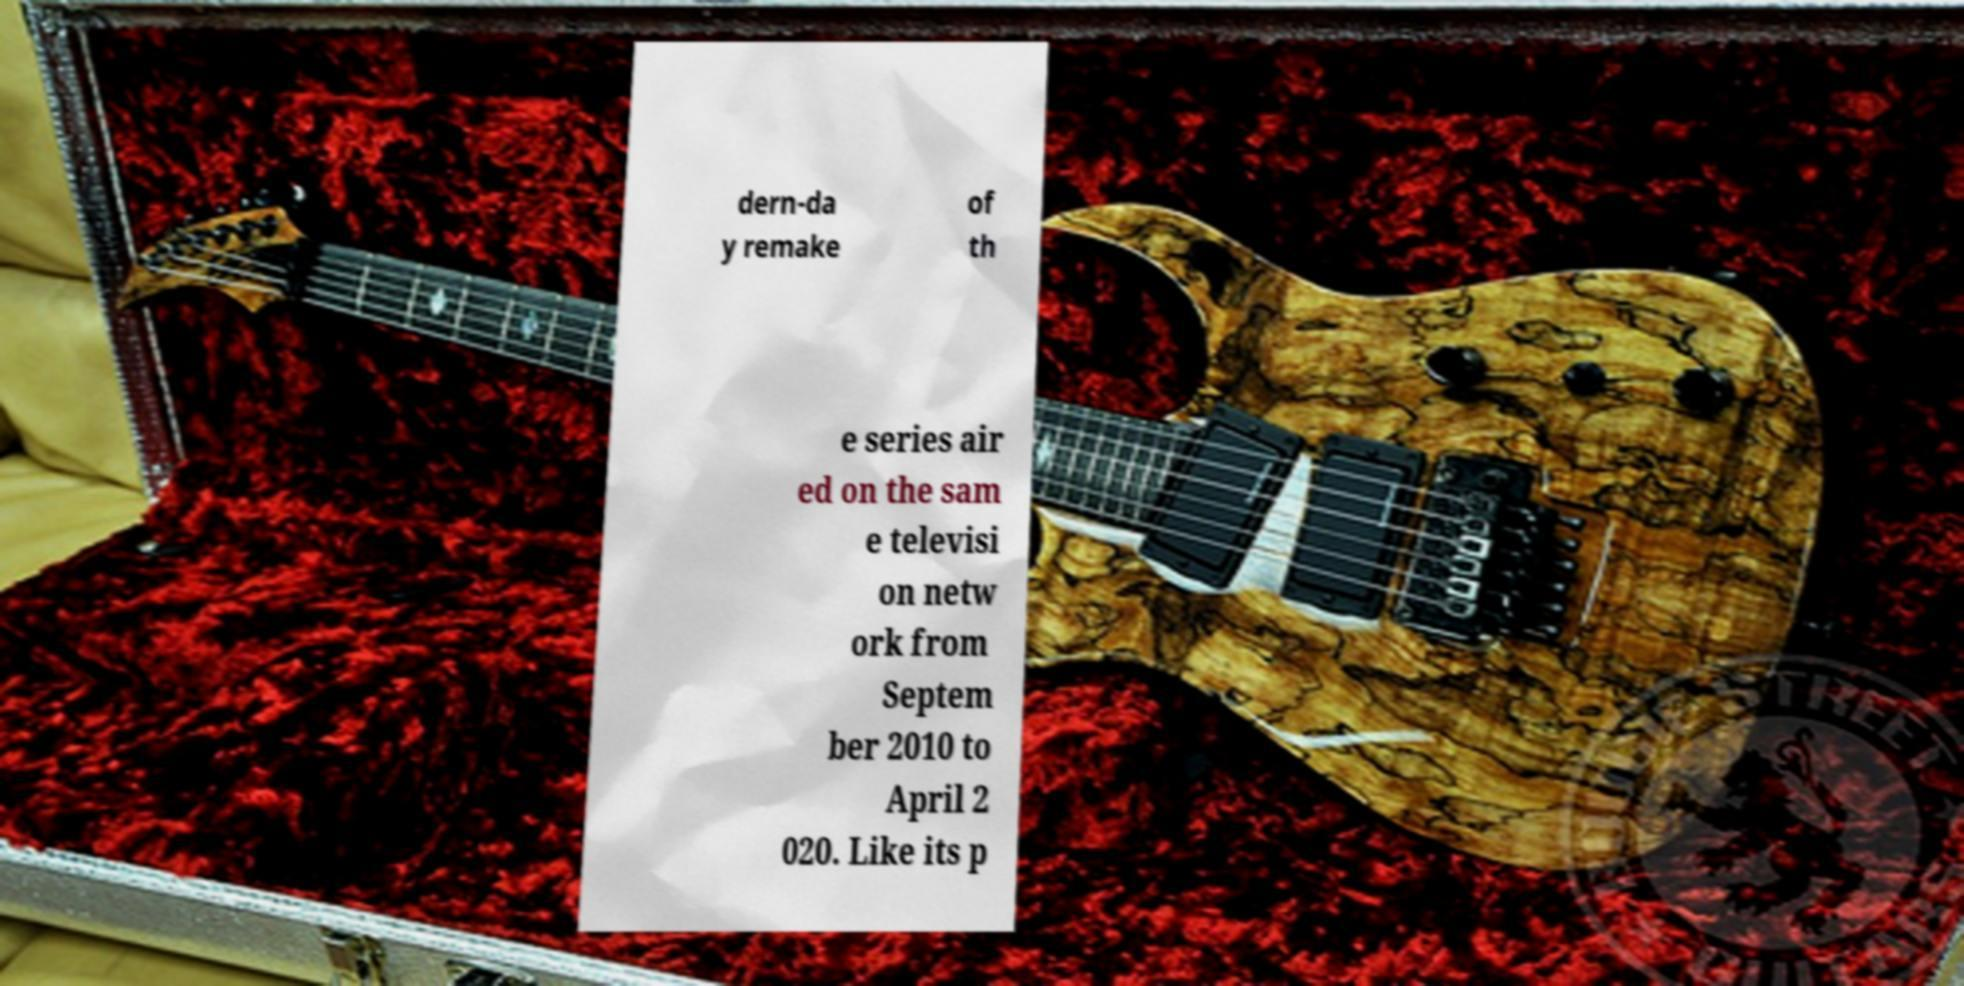For documentation purposes, I need the text within this image transcribed. Could you provide that? dern-da y remake of th e series air ed on the sam e televisi on netw ork from Septem ber 2010 to April 2 020. Like its p 